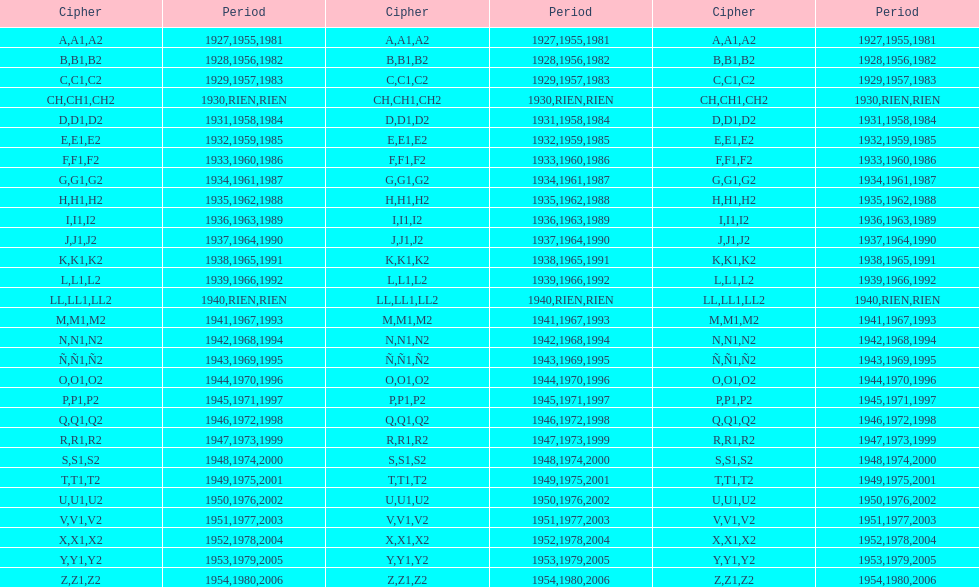Number of codes containing a 2? 28. 